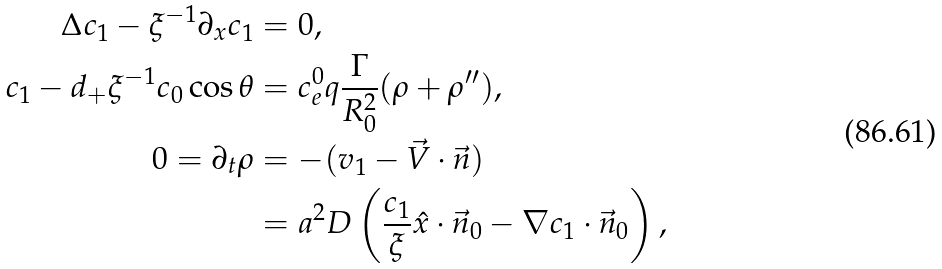Convert formula to latex. <formula><loc_0><loc_0><loc_500><loc_500>\Delta c _ { 1 } - \xi ^ { - 1 } \partial _ { x } c _ { 1 } & = 0 , \\ c _ { 1 } - d _ { + } \xi ^ { - 1 } c _ { 0 } \cos \theta & = c ^ { 0 } _ { e } q \frac { \Gamma } { R _ { 0 } ^ { 2 } } ( \rho + \rho ^ { \prime \prime } ) , \\ 0 = \partial _ { t } \rho & = - ( v _ { 1 } - \vec { V } \cdot \vec { n } ) \\ & = a ^ { 2 } D \left ( \frac { c _ { 1 } } { \xi } \hat { x } \cdot \vec { n } _ { 0 } - \nabla c _ { 1 } \cdot \vec { n } _ { 0 } \right ) ,</formula> 